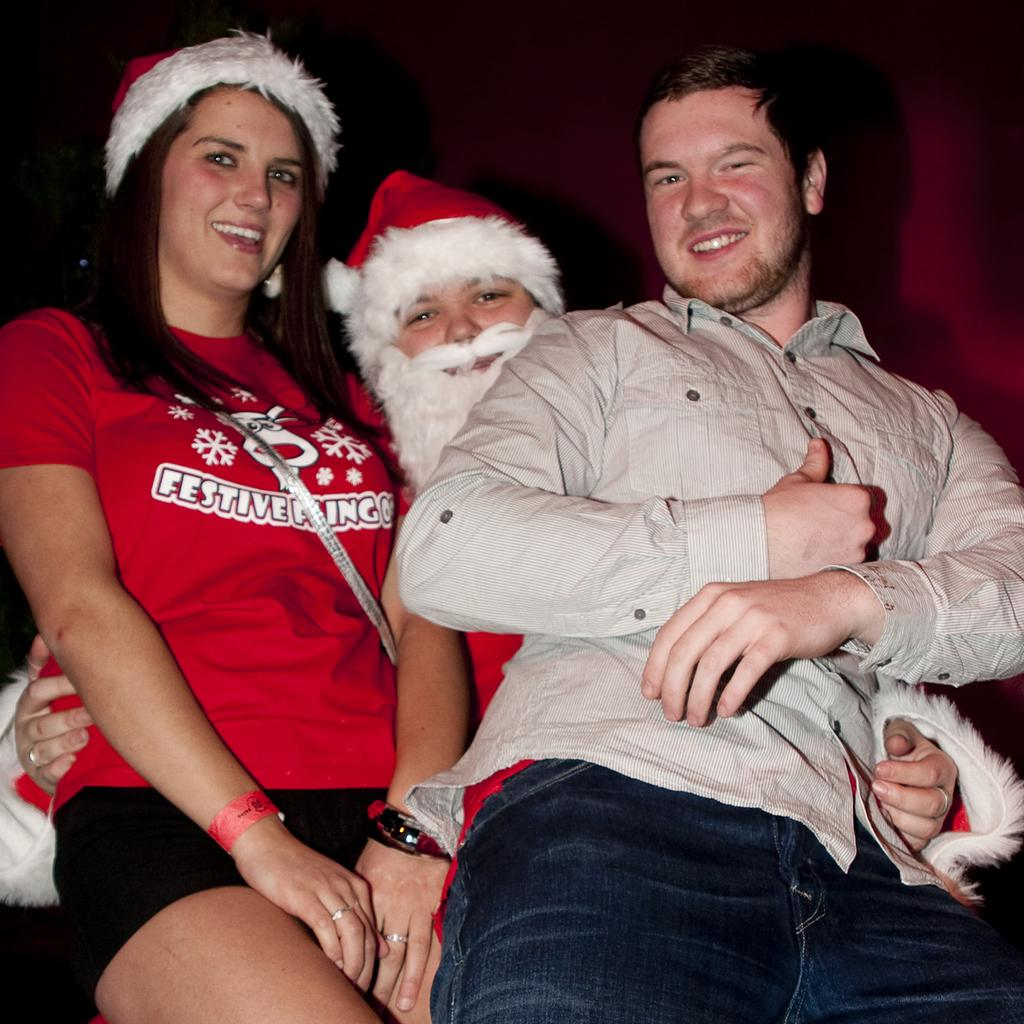Who or what is present in the image? There are people in the image. What are the people doing in the image? The people are smiling. What can be observed about the background of the image? The background of the image is dark. What type of suit is the rice wearing in the image? There is no rice or suit present in the image. 